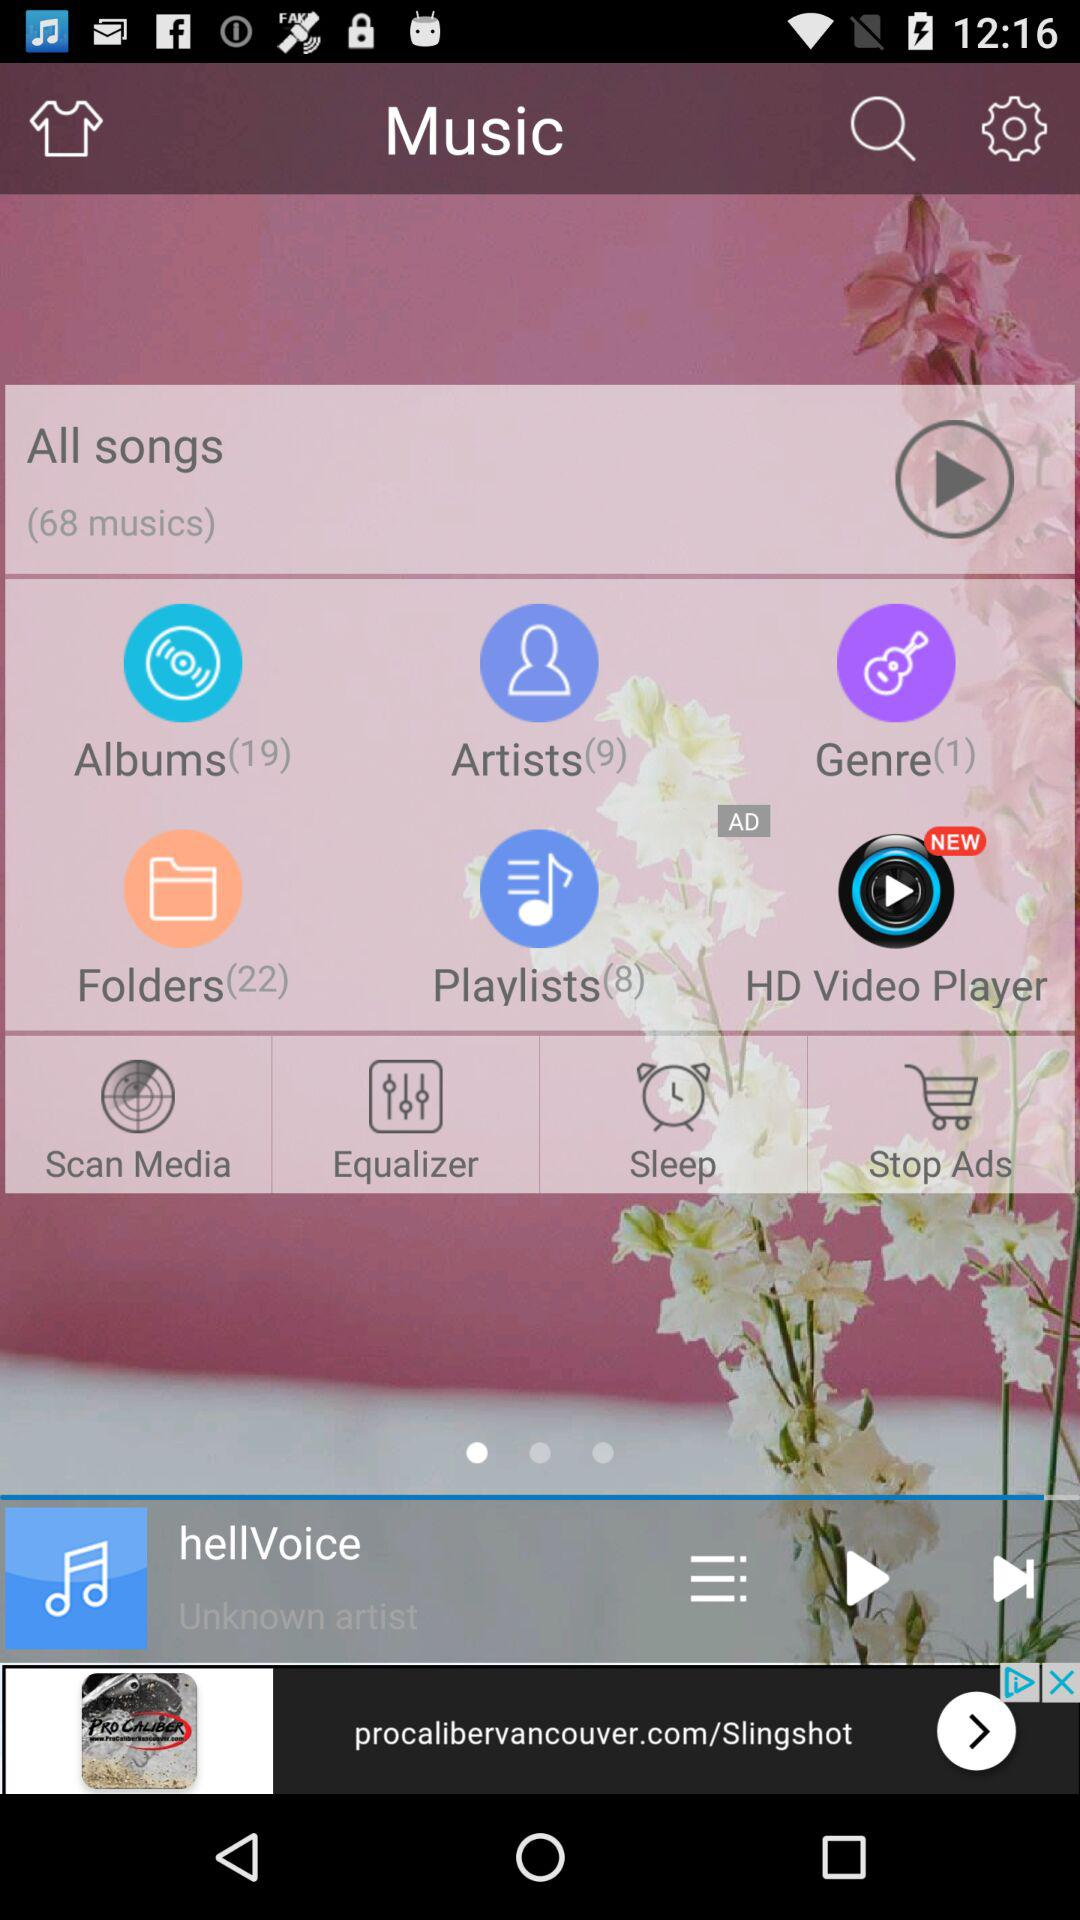How many tracks are there in the "Albums" folder? There are 19 tracks in the "Albums" folder. 